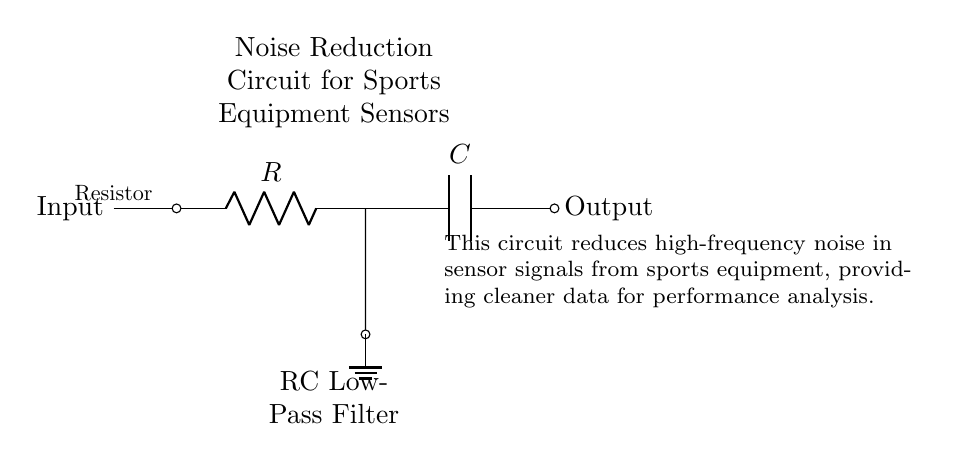What type of filter is this circuit? The diagram labels the filter as an "RC Low-Pass Filter," indicating that it allows low-frequency signals to pass while attenuating high-frequency noise.
Answer: RC Low-Pass Filter What are the components of the circuit? The circuit includes a resistor and a capacitor, as indicated by the labels R and C in the diagram.
Answer: Resistor and Capacitor What is the purpose of this circuit? The explanatory text describes that the circuit is designed for noise reduction in sensor signals from sports equipment, highlighting its purpose for cleaner data in performance analysis.
Answer: Noise reduction Where is the output taken from? The output is indicated to be taken from the right side of the capacitor in the diagram, which is labeled as "Output."
Answer: Output How does this circuit reduce high-frequency noise? The RC low-pass filter works by allowing lower frequencies to pass through while blocking higher frequencies, effectively reducing noise from sensor signals.
Answer: By blocking high frequencies What is the role of the resistor in this circuit? The resistor limits the amount of current flowing through the circuit and, in conjunction with the capacitor, helps set the cutoff frequency for the filter.
Answer: Current limitation What is the significance of the ground connection? The ground connection provides a common reference point for the circuit, ensuring stable operation and signal reference for the noise reduction functionality.
Answer: Common reference point 